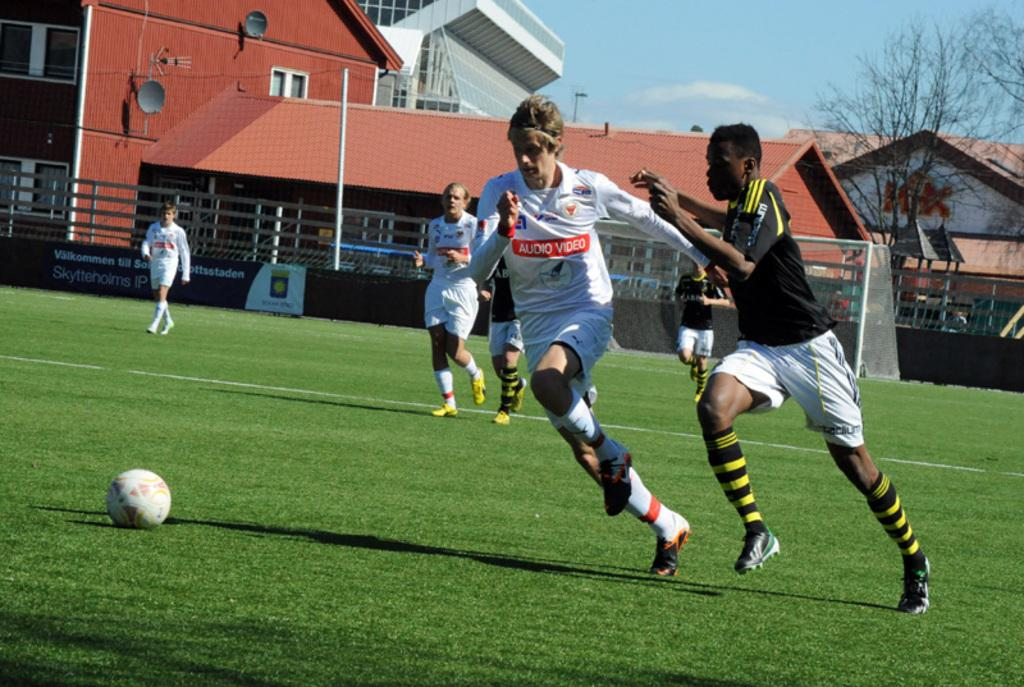<image>
Present a compact description of the photo's key features. Two soccer players, one wearing an "Audio Video" jersey chase the ball. 